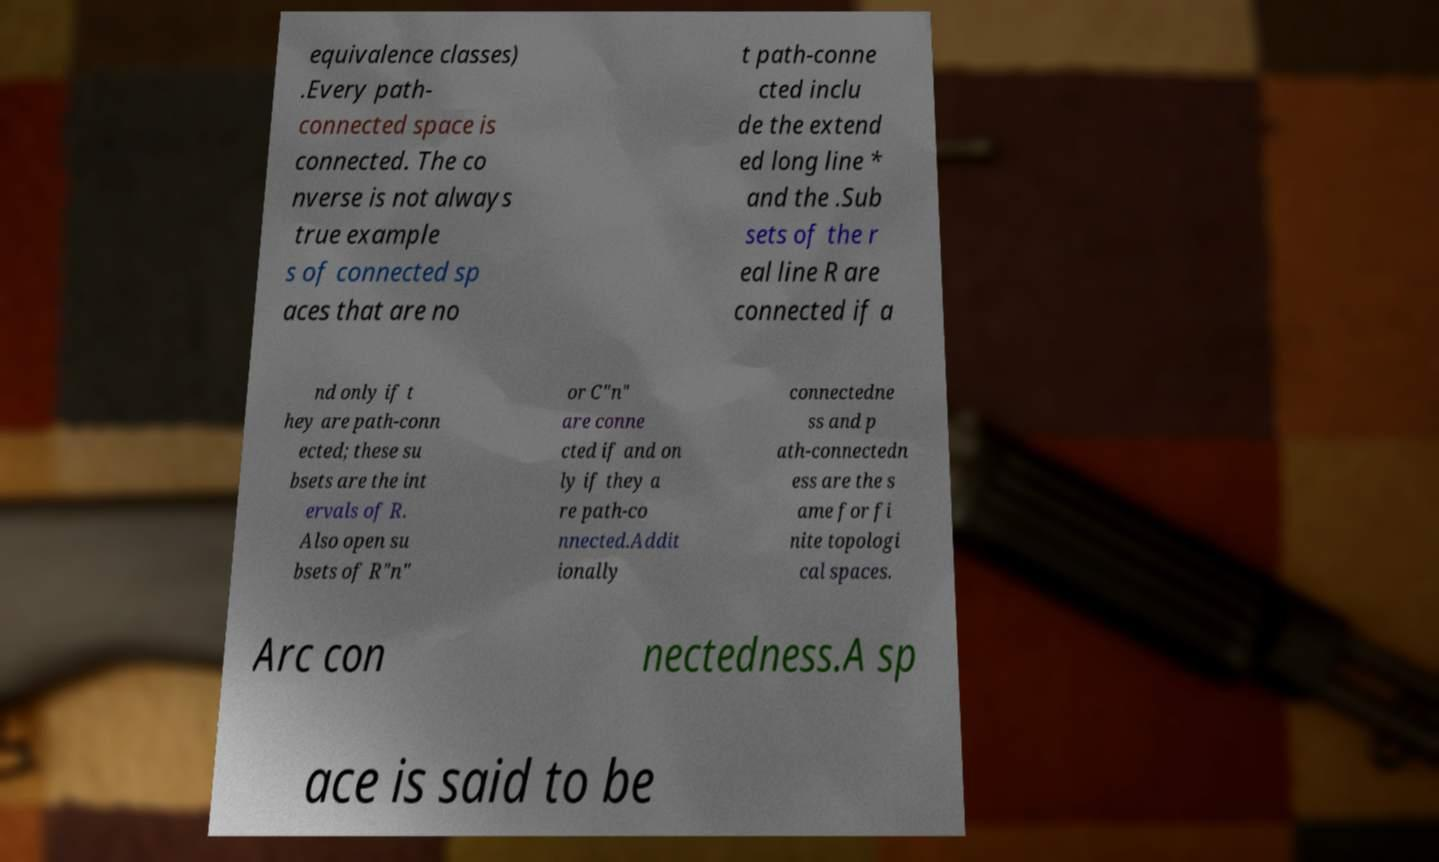Can you read and provide the text displayed in the image?This photo seems to have some interesting text. Can you extract and type it out for me? equivalence classes) .Every path- connected space is connected. The co nverse is not always true example s of connected sp aces that are no t path-conne cted inclu de the extend ed long line * and the .Sub sets of the r eal line R are connected if a nd only if t hey are path-conn ected; these su bsets are the int ervals of R. Also open su bsets of R"n" or C"n" are conne cted if and on ly if they a re path-co nnected.Addit ionally connectedne ss and p ath-connectedn ess are the s ame for fi nite topologi cal spaces. Arc con nectedness.A sp ace is said to be 